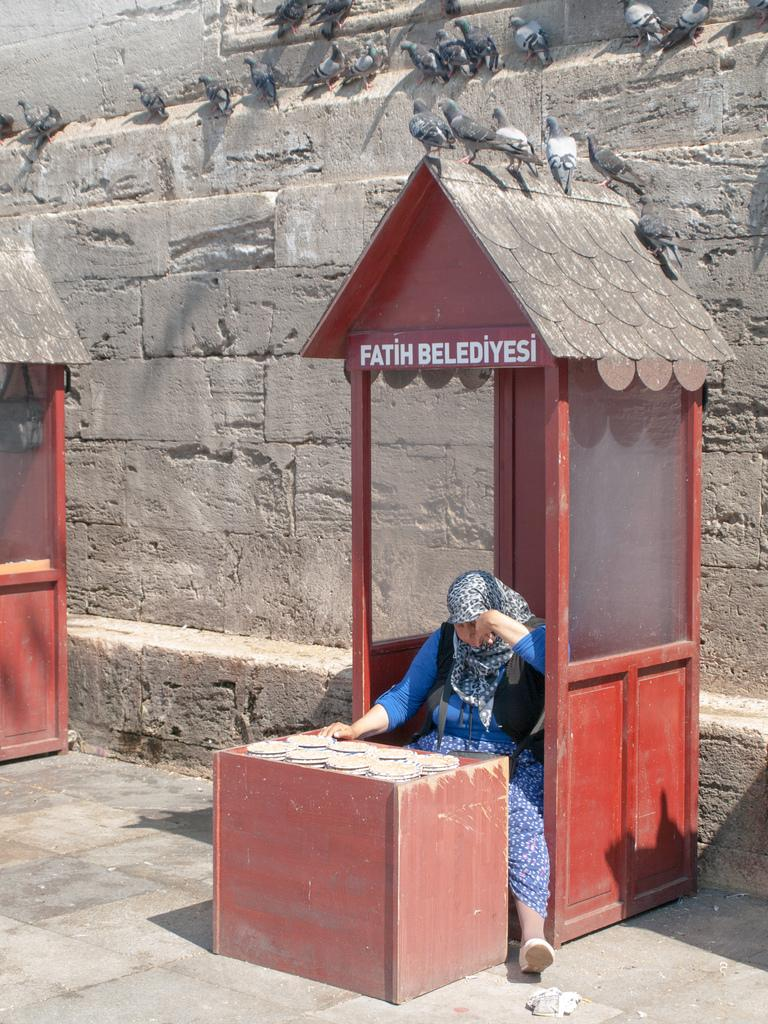Who is present in the image? There is a woman in the image. What is written on the cabin in the image? There is a cabin with text in the image. What can be found on the table in the image? There is an object on the table in the image. What is visible in the background of the image? There is a wall and birds visible in the background of the image. What type of soap is the woman using to clean the zipper on the bag in the image? There is no soap, zipper, or bag present in the image. 